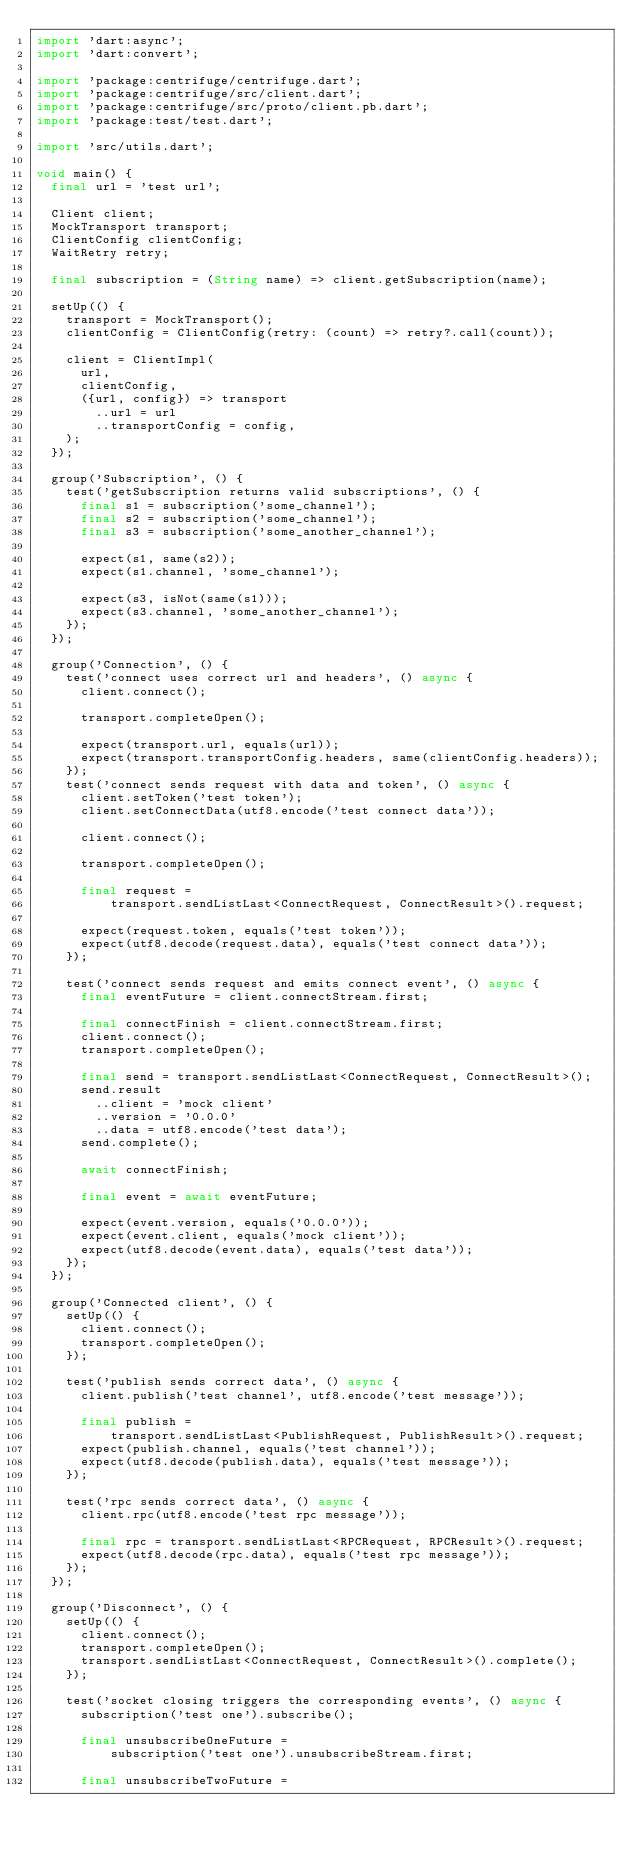<code> <loc_0><loc_0><loc_500><loc_500><_Dart_>import 'dart:async';
import 'dart:convert';

import 'package:centrifuge/centrifuge.dart';
import 'package:centrifuge/src/client.dart';
import 'package:centrifuge/src/proto/client.pb.dart';
import 'package:test/test.dart';

import 'src/utils.dart';

void main() {
  final url = 'test url';

  Client client;
  MockTransport transport;
  ClientConfig clientConfig;
  WaitRetry retry;

  final subscription = (String name) => client.getSubscription(name);

  setUp(() {
    transport = MockTransport();
    clientConfig = ClientConfig(retry: (count) => retry?.call(count));

    client = ClientImpl(
      url,
      clientConfig,
      ({url, config}) => transport
        ..url = url
        ..transportConfig = config,
    );
  });

  group('Subscription', () {
    test('getSubscription returns valid subscriptions', () {
      final s1 = subscription('some_channel');
      final s2 = subscription('some_channel');
      final s3 = subscription('some_another_channel');

      expect(s1, same(s2));
      expect(s1.channel, 'some_channel');

      expect(s3, isNot(same(s1)));
      expect(s3.channel, 'some_another_channel');
    });
  });

  group('Connection', () {
    test('connect uses correct url and headers', () async {
      client.connect();

      transport.completeOpen();

      expect(transport.url, equals(url));
      expect(transport.transportConfig.headers, same(clientConfig.headers));
    });
    test('connect sends request with data and token', () async {
      client.setToken('test token');
      client.setConnectData(utf8.encode('test connect data'));

      client.connect();

      transport.completeOpen();

      final request =
          transport.sendListLast<ConnectRequest, ConnectResult>().request;

      expect(request.token, equals('test token'));
      expect(utf8.decode(request.data), equals('test connect data'));
    });

    test('connect sends request and emits connect event', () async {
      final eventFuture = client.connectStream.first;

      final connectFinish = client.connectStream.first;
      client.connect();
      transport.completeOpen();

      final send = transport.sendListLast<ConnectRequest, ConnectResult>();
      send.result
        ..client = 'mock client'
        ..version = '0.0.0'
        ..data = utf8.encode('test data');
      send.complete();

      await connectFinish;

      final event = await eventFuture;

      expect(event.version, equals('0.0.0'));
      expect(event.client, equals('mock client'));
      expect(utf8.decode(event.data), equals('test data'));
    });
  });

  group('Connected client', () {
    setUp(() {
      client.connect();
      transport.completeOpen();
    });

    test('publish sends correct data', () async {
      client.publish('test channel', utf8.encode('test message'));

      final publish =
          transport.sendListLast<PublishRequest, PublishResult>().request;
      expect(publish.channel, equals('test channel'));
      expect(utf8.decode(publish.data), equals('test message'));
    });

    test('rpc sends correct data', () async {
      client.rpc(utf8.encode('test rpc message'));

      final rpc = transport.sendListLast<RPCRequest, RPCResult>().request;
      expect(utf8.decode(rpc.data), equals('test rpc message'));
    });
  });

  group('Disconnect', () {
    setUp(() {
      client.connect();
      transport.completeOpen();
      transport.sendListLast<ConnectRequest, ConnectResult>().complete();
    });

    test('socket closing triggers the corresponding events', () async {
      subscription('test one').subscribe();

      final unsubscribeOneFuture =
          subscription('test one').unsubscribeStream.first;

      final unsubscribeTwoFuture =</code> 